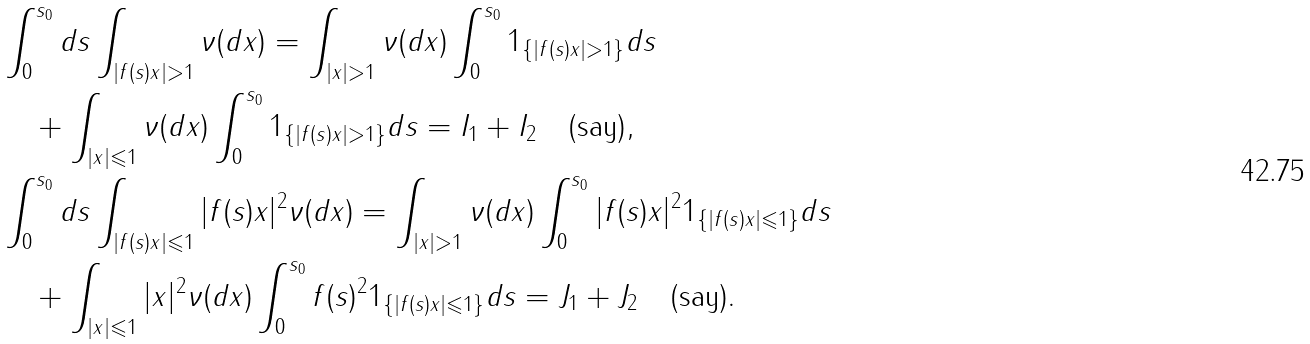Convert formula to latex. <formula><loc_0><loc_0><loc_500><loc_500>& \int _ { 0 } ^ { s _ { 0 } } d s \int _ { | f ( s ) x | > 1 } \nu ( d x ) = \int _ { | x | > 1 } \nu ( d x ) \int _ { 0 } ^ { s _ { 0 } } 1 _ { \{ | f ( s ) x | > 1 \} } d s \\ & \quad + \int _ { | x | \leqslant 1 } \nu ( d x ) \int _ { 0 } ^ { s _ { 0 } } 1 _ { \{ | f ( s ) x | > 1 \} } d s = I _ { 1 } + I _ { 2 } \quad \text {(say)} , \\ & \int _ { 0 } ^ { s _ { 0 } } d s \int _ { | f ( s ) x | \leqslant 1 } | f ( s ) x | ^ { 2 } \nu ( d x ) = \int _ { | x | > 1 } \nu ( d x ) \int _ { 0 } ^ { s _ { 0 } } | f ( s ) x | ^ { 2 } 1 _ { \{ | f ( s ) x | \leqslant 1 \} } d s \\ & \quad + \int _ { | x | \leqslant 1 } | x | ^ { 2 } \nu ( d x ) \int _ { 0 } ^ { s _ { 0 } } f ( s ) ^ { 2 } 1 _ { \{ | f ( s ) x | \leqslant 1 \} } d s = J _ { 1 } + J _ { 2 } \quad \text {(say)} .</formula> 